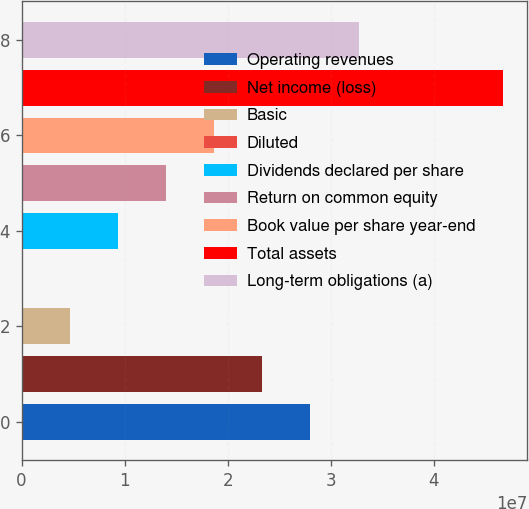Convert chart. <chart><loc_0><loc_0><loc_500><loc_500><bar_chart><fcel>Operating revenues<fcel>Net income (loss)<fcel>Basic<fcel>Diluted<fcel>Dividends declared per share<fcel>Return on common equity<fcel>Book value per share year-end<fcel>Total assets<fcel>Long-term obligations (a)<nl><fcel>2.80243e+07<fcel>2.33536e+07<fcel>4.67072e+06<fcel>2.28<fcel>9.34143e+06<fcel>1.40121e+07<fcel>1.86829e+07<fcel>4.67071e+07<fcel>3.2695e+07<nl></chart> 